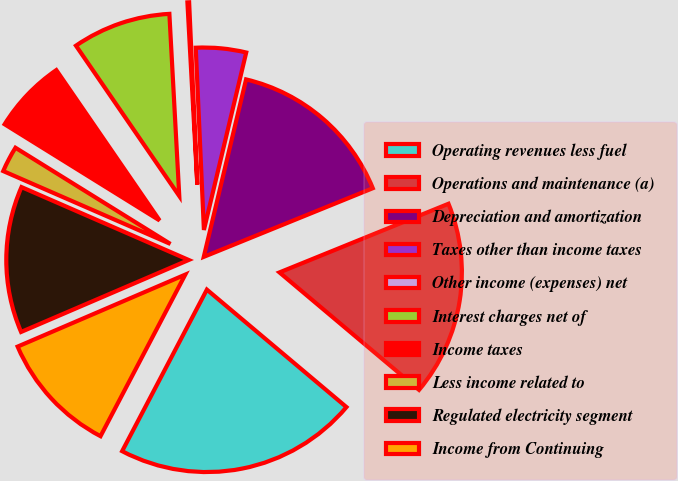Convert chart to OTSL. <chart><loc_0><loc_0><loc_500><loc_500><pie_chart><fcel>Operating revenues less fuel<fcel>Operations and maintenance (a)<fcel>Depreciation and amortization<fcel>Taxes other than income taxes<fcel>Other income (expenses) net<fcel>Interest charges net of<fcel>Income taxes<fcel>Less income related to<fcel>Regulated electricity segment<fcel>Income from Continuing<nl><fcel>21.56%<fcel>17.28%<fcel>15.14%<fcel>4.44%<fcel>0.15%<fcel>8.72%<fcel>6.58%<fcel>2.3%<fcel>13.0%<fcel>10.86%<nl></chart> 